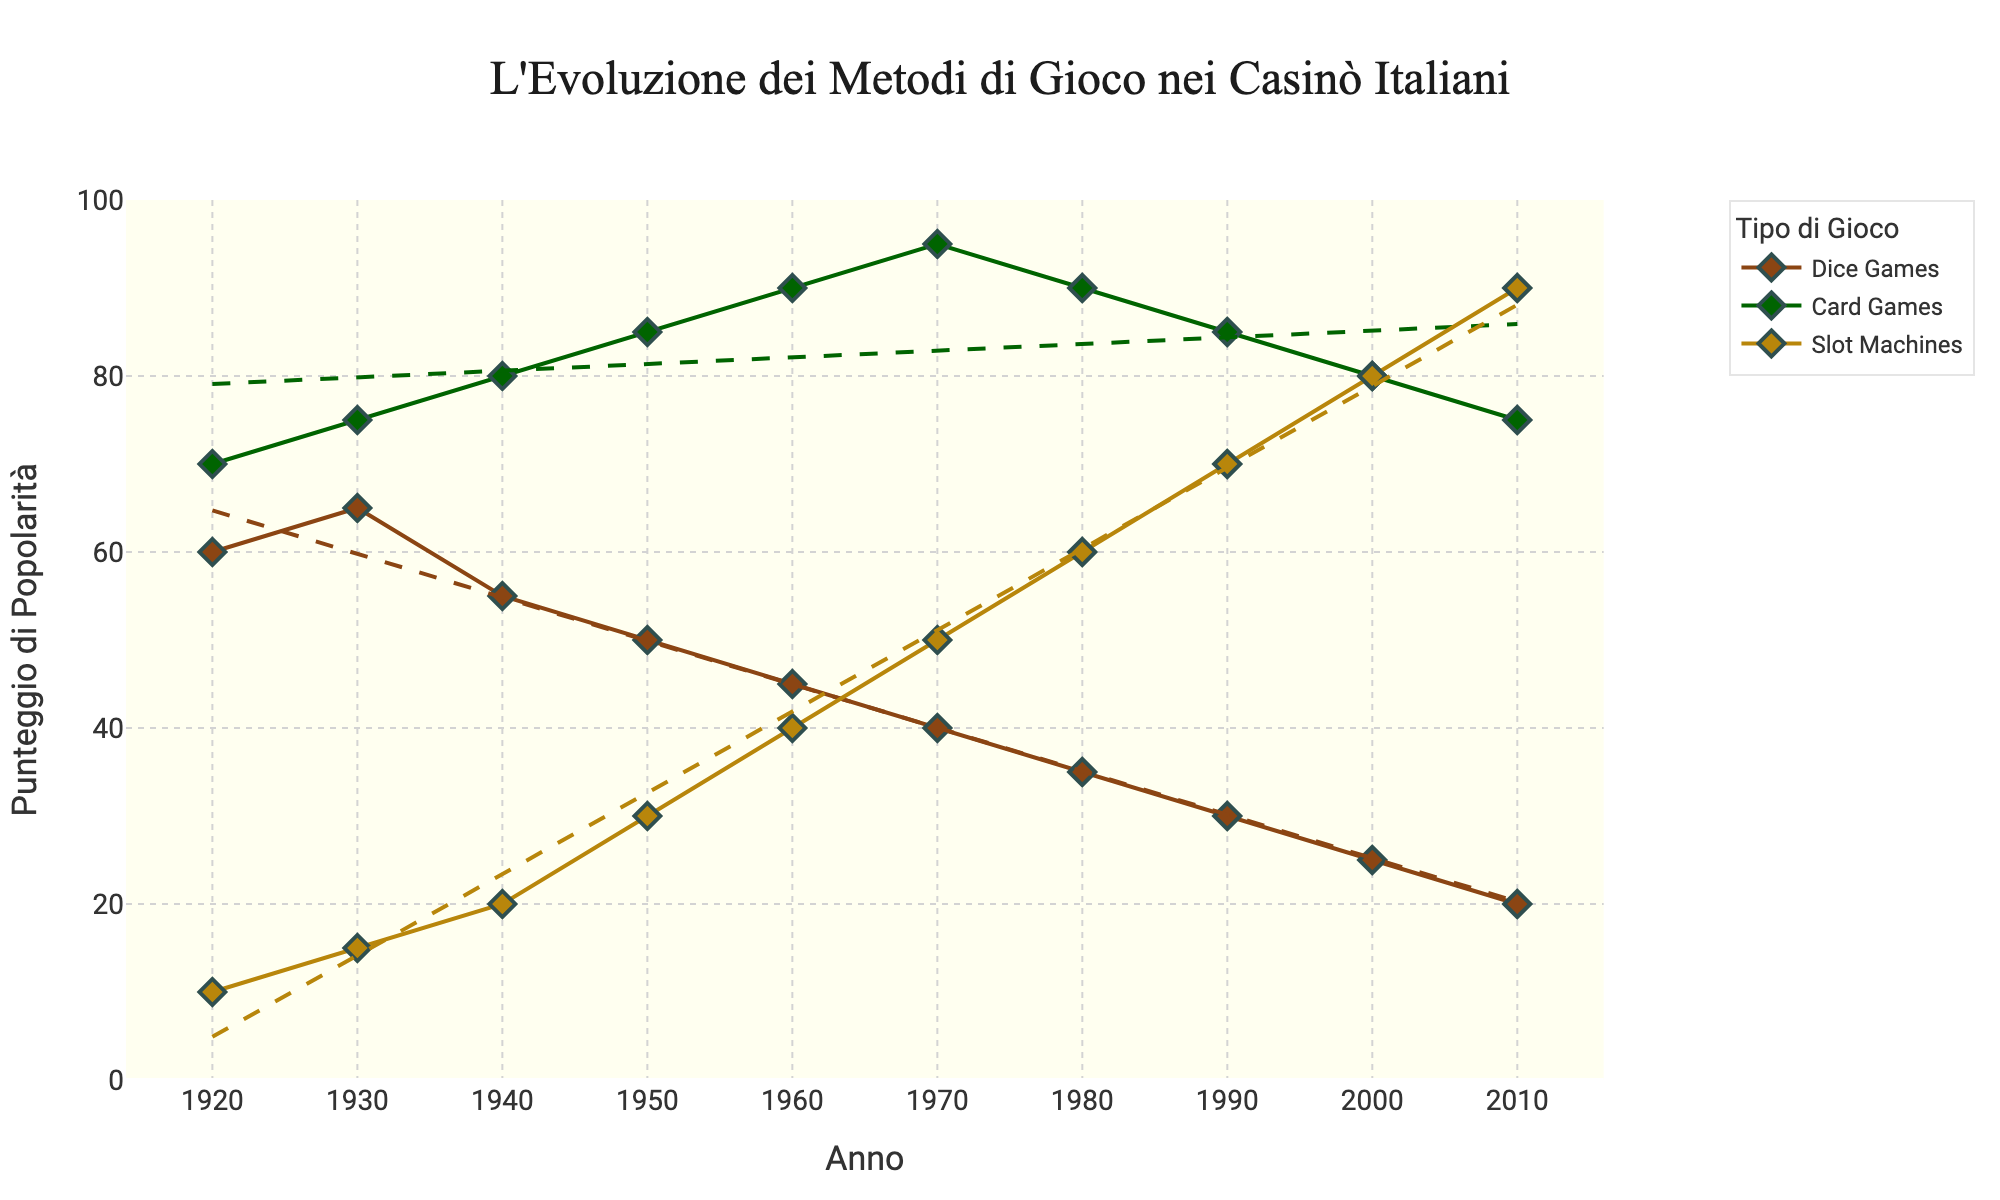Which game type had the highest popularity score in the 1920s? The scatter plot shows the popularity scores for each game type in the 1920s. By comparing the points, you can see that Card Games have a score of 70, which is higher than Dice Games (60) and Slot Machines (10).
Answer: Card Games How did the popularity of Dice Games change from 1920 to 2010? To determine this, look at the trend line and data points for Dice Games from 1920 to 2010. The popularity score starts at 60 in 1920 and decreases to 20 in 2010, indicating a downward trend.
Answer: Decreased What's the slope of the trend line for Slot Machines? The trend line for Slot Machines can be derived from its equation in the plot. This line represents the general trend. The slope signifies the rate of change. The trend line goes from 10 in 1920 to 90 in 2010, giving a rough slope of (90-10)/(2010-1920) = 80/90 ≈ 0.89.
Answer: Approximately 0.89 Between which decades did Card Games experience the steepest decline in popularity? To find the steepest decline, look for the largest drop in popularity scores between decades for Card Games. The chart shows that the score drops from 95 in 1970 to 90 in 1980 (-5), from 90 in 1980 to 85 in 1990 (-5), and from 85 in 1990 to 80 in 2000 (-5). However, the largest decade drop is from 80 in 2000 to 75 in 2010 (-5). Thus, overall the steepest decline occurred from 1970 to 2010 as the trend line shows a consistent drop by 20 points.
Answer: 1970-2010 Compare the 2010 popularity score of Slot Machines and Dice Games. Look at the final data points in 2010 for both Slot Machines and Dice Games. Slot Machines have a score of 90, and Dice Games have a score of 20.
Answer: Slot Machines: 90, Dice Games: 20 What is the difference in popularity scores of Dice Games and Card Games in 1950? From the scatter plot, identify the scores for Dice Games and Card Games in 1950. Dice Games have a score of 50, while Card Games have a score of 85. Subtracting these gives 85 - 50 = 35.
Answer: 35 Identify the game type that showed a continual increase in popularity from 1920 to 2010. The scatter plot and trend lines indicate that Slot Machines steadily increased in popularity from 10 in 1920 to 90 in 2010.
Answer: Slot Machines Which decade saw the highest popularity score for Card Games? Examine the data points for Card Games across all decades. The highest score is 95, which occurs in 1970.
Answer: 1970 How does the trend line of Card Games from 1960 to 2010 compare with that of Slot Machines? Look at the trend lines for both Card Games and Slot Machines from 1960 to 2010. The trend for Card Games shows a decline from a peak in the 1970s, while Slot Machines show a steady incline over the same period.
Answer: Card Games: Decline, Slot Machines: Incline 